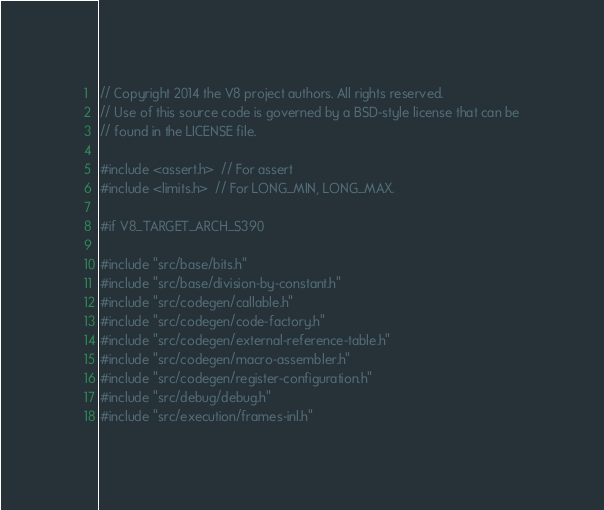<code> <loc_0><loc_0><loc_500><loc_500><_C++_>// Copyright 2014 the V8 project authors. All rights reserved.
// Use of this source code is governed by a BSD-style license that can be
// found in the LICENSE file.

#include <assert.h>  // For assert
#include <limits.h>  // For LONG_MIN, LONG_MAX.

#if V8_TARGET_ARCH_S390

#include "src/base/bits.h"
#include "src/base/division-by-constant.h"
#include "src/codegen/callable.h"
#include "src/codegen/code-factory.h"
#include "src/codegen/external-reference-table.h"
#include "src/codegen/macro-assembler.h"
#include "src/codegen/register-configuration.h"
#include "src/debug/debug.h"
#include "src/execution/frames-inl.h"</code> 